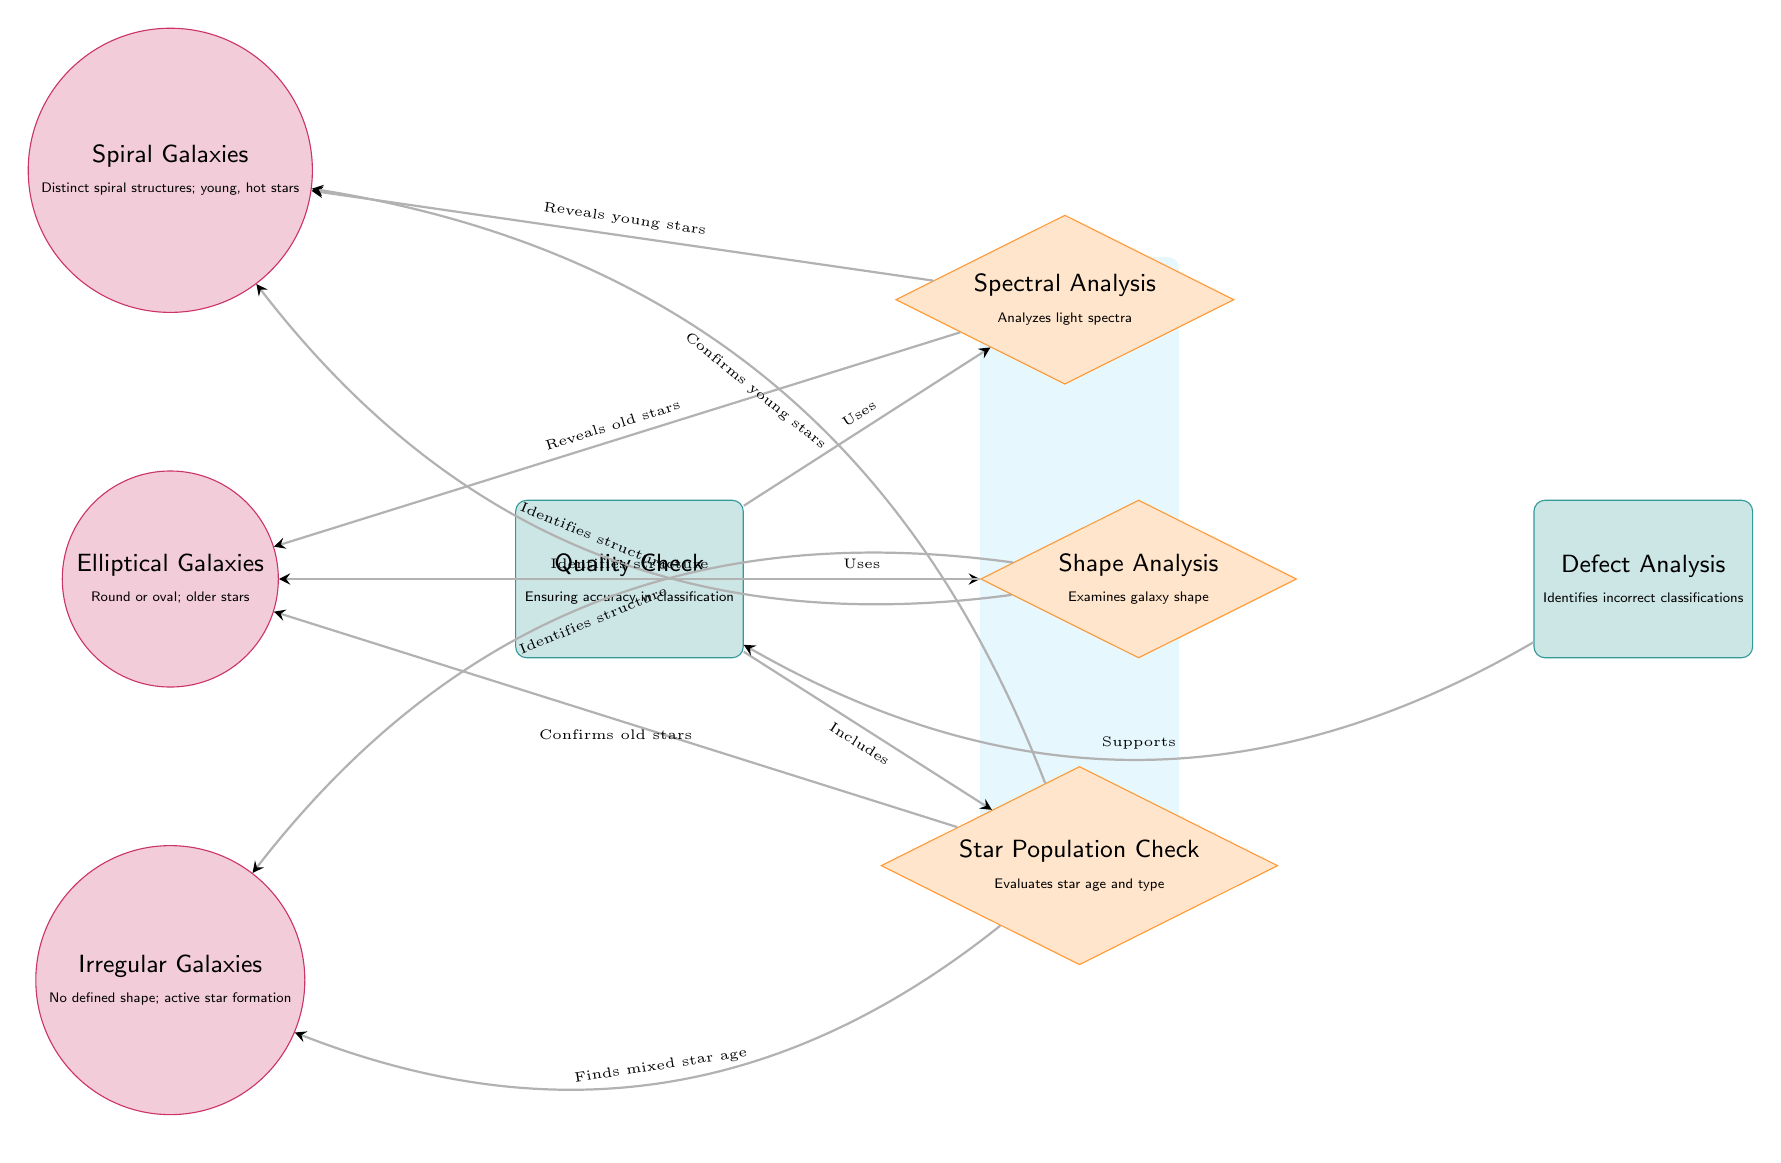What type of galaxies are represented? The diagram includes three types of galaxies: Spiral, Elliptical, and Irregular, each defined by distinct characteristics.
Answer: Spiral, Elliptical, Irregular What is the main characteristic of elliptical galaxies? The diagram specifies that elliptical galaxies are described as "Round or oval; older stars," highlighting their shape and star population.
Answer: Round or oval; older stars Which analysis checks the shape of galaxies? According to the diagram, the "Shape Analysis" node is explicitly labeled, indicating its role in examining the structure of galaxies.
Answer: Shape Analysis What purpose does the Quality Check serve in the diagram? The Quality Check node is described as ensuring accuracy in classification, connecting quality control to the identification of galaxy types.
Answer: Ensuring accuracy in classification Which galaxy type is confirmed to have young stars? The "Star Population Check" node indicates that it confirms young stars for spiral galaxies, which means they belong to this category.
Answer: Spiral How is defect analysis related to quality checks? The defect analysis supports quality checks by identifying incorrect classifications, illustrating a direct flow from quality checks to defect analysis.
Answer: Supports What does spectral analysis reveal for elliptical galaxies? The spectral analysis connects to the elliptical node, revealing old stars specifically for this galaxy type through light spectra examination.
Answer: Reveals old stars What characteristic does shape analysis identify for irregular galaxies? The shape analysis indicates that it identifies structures for irregular galaxies, even though they lack defined shapes, showing its broader classification role.
Answer: Identifies structure Which type of galaxy has active star formation? The diagram informs that irregular galaxies are associated with active star formation, which is a defining trait.
Answer: Irregular Galaxies 